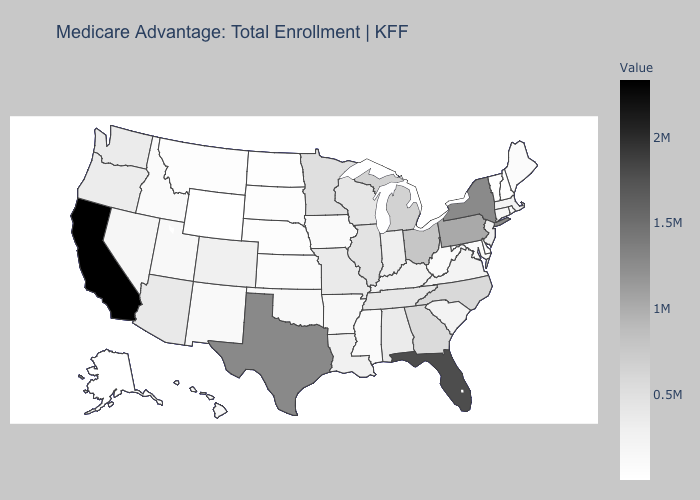Which states have the highest value in the USA?
Be succinct. California. Which states have the lowest value in the South?
Answer briefly. Delaware. Which states have the lowest value in the MidWest?
Short answer required. North Dakota. Does Missouri have the lowest value in the MidWest?
Short answer required. No. Which states have the lowest value in the USA?
Be succinct. Alaska. Does California have the highest value in the USA?
Give a very brief answer. Yes. Among the states that border New Jersey , which have the lowest value?
Answer briefly. Delaware. Which states have the lowest value in the Northeast?
Concise answer only. Vermont. 